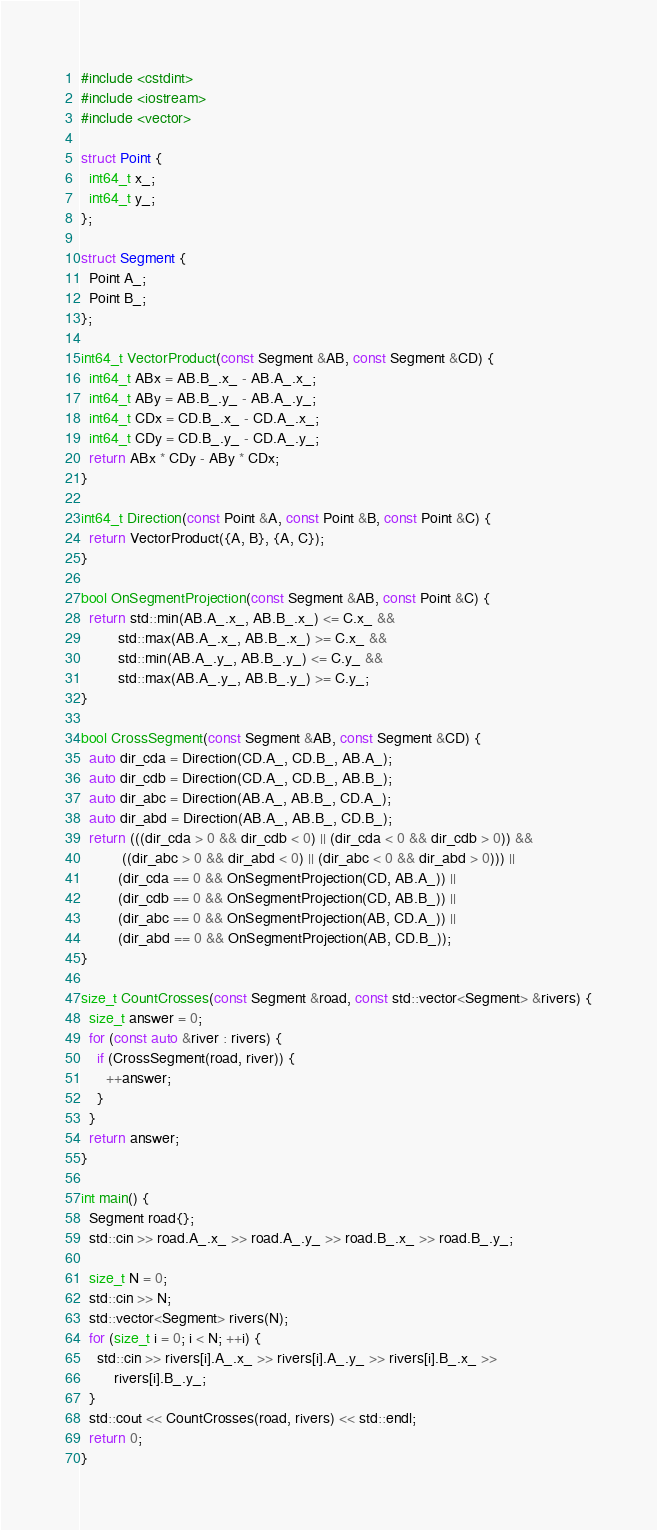<code> <loc_0><loc_0><loc_500><loc_500><_C++_>#include <cstdint>
#include <iostream>
#include <vector>

struct Point {
  int64_t x_;
  int64_t y_;
};

struct Segment {
  Point A_;
  Point B_;
};

int64_t VectorProduct(const Segment &AB, const Segment &CD) {
  int64_t ABx = AB.B_.x_ - AB.A_.x_;
  int64_t ABy = AB.B_.y_ - AB.A_.y_;
  int64_t CDx = CD.B_.x_ - CD.A_.x_;
  int64_t CDy = CD.B_.y_ - CD.A_.y_;
  return ABx * CDy - ABy * CDx;
}

int64_t Direction(const Point &A, const Point &B, const Point &C) {
  return VectorProduct({A, B}, {A, C});
}

bool OnSegmentProjection(const Segment &AB, const Point &C) {
  return std::min(AB.A_.x_, AB.B_.x_) <= C.x_ &&
         std::max(AB.A_.x_, AB.B_.x_) >= C.x_ &&
         std::min(AB.A_.y_, AB.B_.y_) <= C.y_ &&
         std::max(AB.A_.y_, AB.B_.y_) >= C.y_;
}

bool CrossSegment(const Segment &AB, const Segment &CD) {
  auto dir_cda = Direction(CD.A_, CD.B_, AB.A_);
  auto dir_cdb = Direction(CD.A_, CD.B_, AB.B_);
  auto dir_abc = Direction(AB.A_, AB.B_, CD.A_);
  auto dir_abd = Direction(AB.A_, AB.B_, CD.B_);
  return (((dir_cda > 0 && dir_cdb < 0) || (dir_cda < 0 && dir_cdb > 0)) &&
          ((dir_abc > 0 && dir_abd < 0) || (dir_abc < 0 && dir_abd > 0))) ||
         (dir_cda == 0 && OnSegmentProjection(CD, AB.A_)) ||
         (dir_cdb == 0 && OnSegmentProjection(CD, AB.B_)) ||
         (dir_abc == 0 && OnSegmentProjection(AB, CD.A_)) ||
         (dir_abd == 0 && OnSegmentProjection(AB, CD.B_));
}

size_t CountCrosses(const Segment &road, const std::vector<Segment> &rivers) {
  size_t answer = 0;
  for (const auto &river : rivers) {
    if (CrossSegment(road, river)) {
      ++answer;
    }
  }
  return answer;
}

int main() {
  Segment road{};
  std::cin >> road.A_.x_ >> road.A_.y_ >> road.B_.x_ >> road.B_.y_;

  size_t N = 0;
  std::cin >> N;
  std::vector<Segment> rivers(N);
  for (size_t i = 0; i < N; ++i) {
    std::cin >> rivers[i].A_.x_ >> rivers[i].A_.y_ >> rivers[i].B_.x_ >>
        rivers[i].B_.y_;
  }
  std::cout << CountCrosses(road, rivers) << std::endl;
  return 0;
}</code> 